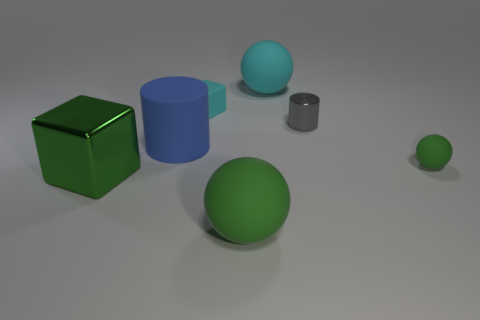How many things are either green matte balls that are in front of the tiny gray object or big green cubes?
Provide a short and direct response. 3. What is the shape of the tiny matte object that is to the left of the small thing that is in front of the big blue rubber object?
Provide a succinct answer. Cube. There is a cyan object that is left of the large cyan object; does it have the same shape as the large green shiny thing?
Your answer should be very brief. Yes. What color is the small matte thing right of the tiny cyan thing?
Offer a terse response. Green. What number of cylinders are either large cyan matte objects or big green metallic objects?
Provide a succinct answer. 0. What is the size of the sphere that is in front of the big green metallic thing in front of the small green thing?
Offer a terse response. Large. Is the color of the tiny cube the same as the big ball behind the small gray metallic cylinder?
Your answer should be very brief. Yes. What number of small balls are in front of the big cyan rubber ball?
Your response must be concise. 1. Is the number of small gray things less than the number of green spheres?
Provide a short and direct response. Yes. There is a ball that is left of the small metallic cylinder and in front of the gray object; how big is it?
Your answer should be compact. Large. 